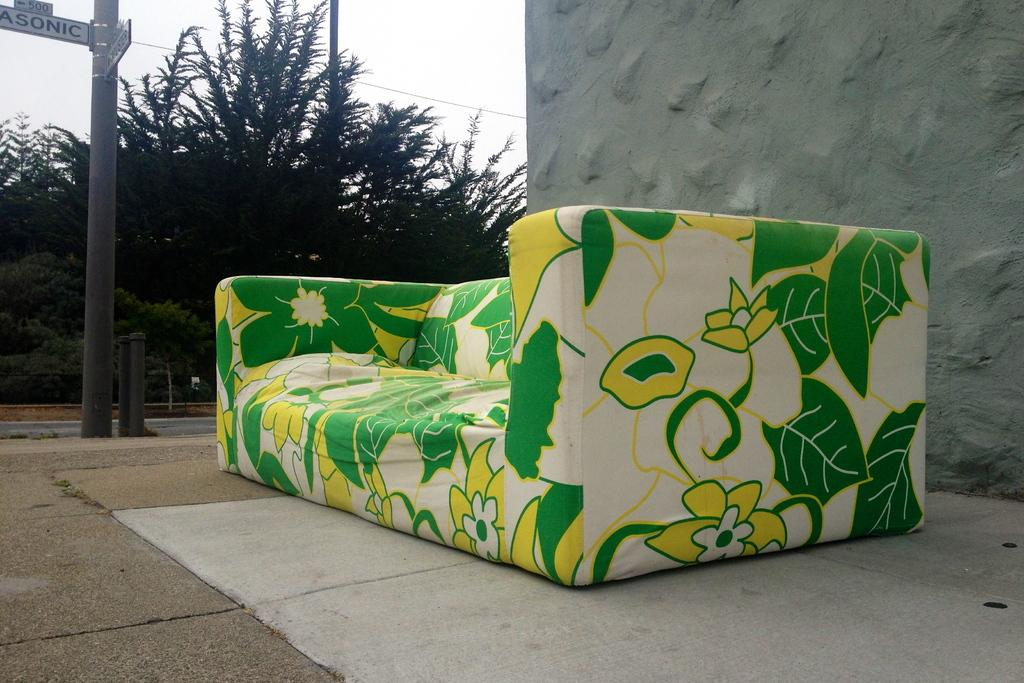What is the main piece of furniture in the image? There is a beautiful sofa in the middle of the image. What can be seen in the background of the image? There is a pole, a wall, trees, and the sky visible in the background of the image. What type of calculator is being used on the sofa in the image? There is no calculator present in the image; it features a beautiful sofa and various background elements. 